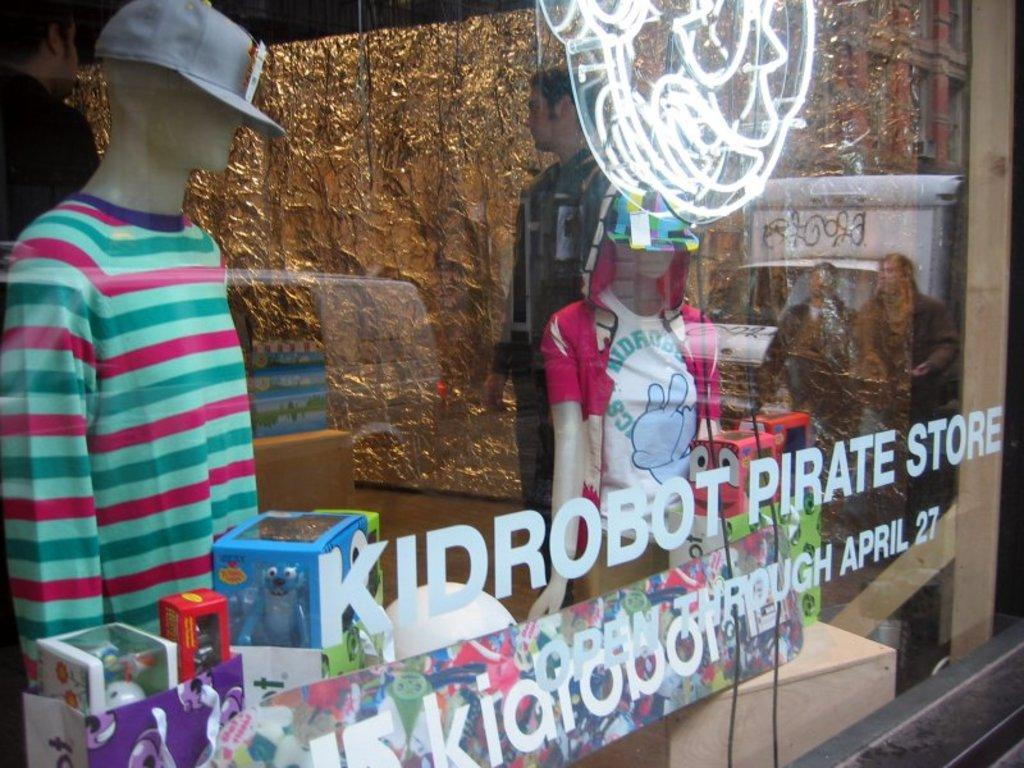What type of figures are wearing dresses in the image? There are mannequins with dresses in the image. What can be seen on the table in the image? There are objects on a table in the image. What is visible in the image that might be related to electricity or communication? There are wires visible in the image. What is written or displayed on the glass window in the image? There is text on a glass window in the image. Can you describe the people in the image? There are people in the image. What type of feast is being prepared in the image? There is no indication of a feast being prepared in the image. Where is the mailbox located in the image? There is no mailbox present in the image. 